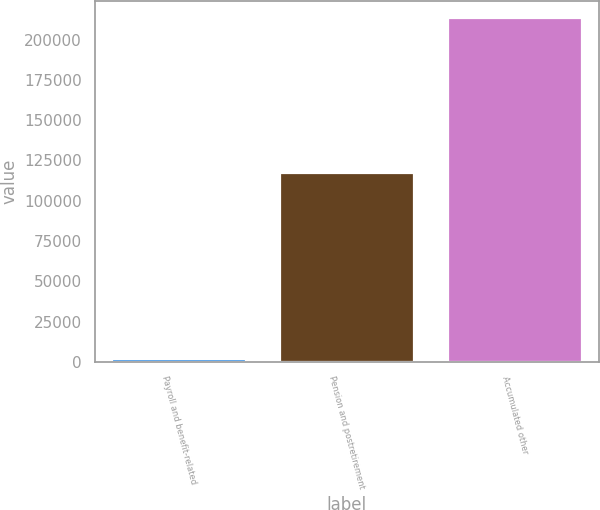Convert chart. <chart><loc_0><loc_0><loc_500><loc_500><bar_chart><fcel>Payroll and benefit-related<fcel>Pension and postretirement<fcel>Accumulated other<nl><fcel>1779<fcel>117355<fcel>213117<nl></chart> 